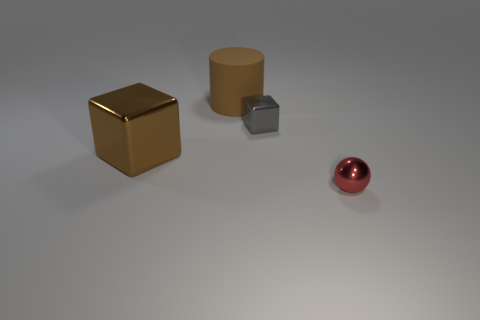Add 4 red spheres. How many objects exist? 8 Subtract all cylinders. How many objects are left? 3 Subtract all large brown rubber cylinders. Subtract all brown objects. How many objects are left? 1 Add 4 tiny gray metal cubes. How many tiny gray metal cubes are left? 5 Add 4 large green objects. How many large green objects exist? 4 Subtract 0 purple cylinders. How many objects are left? 4 